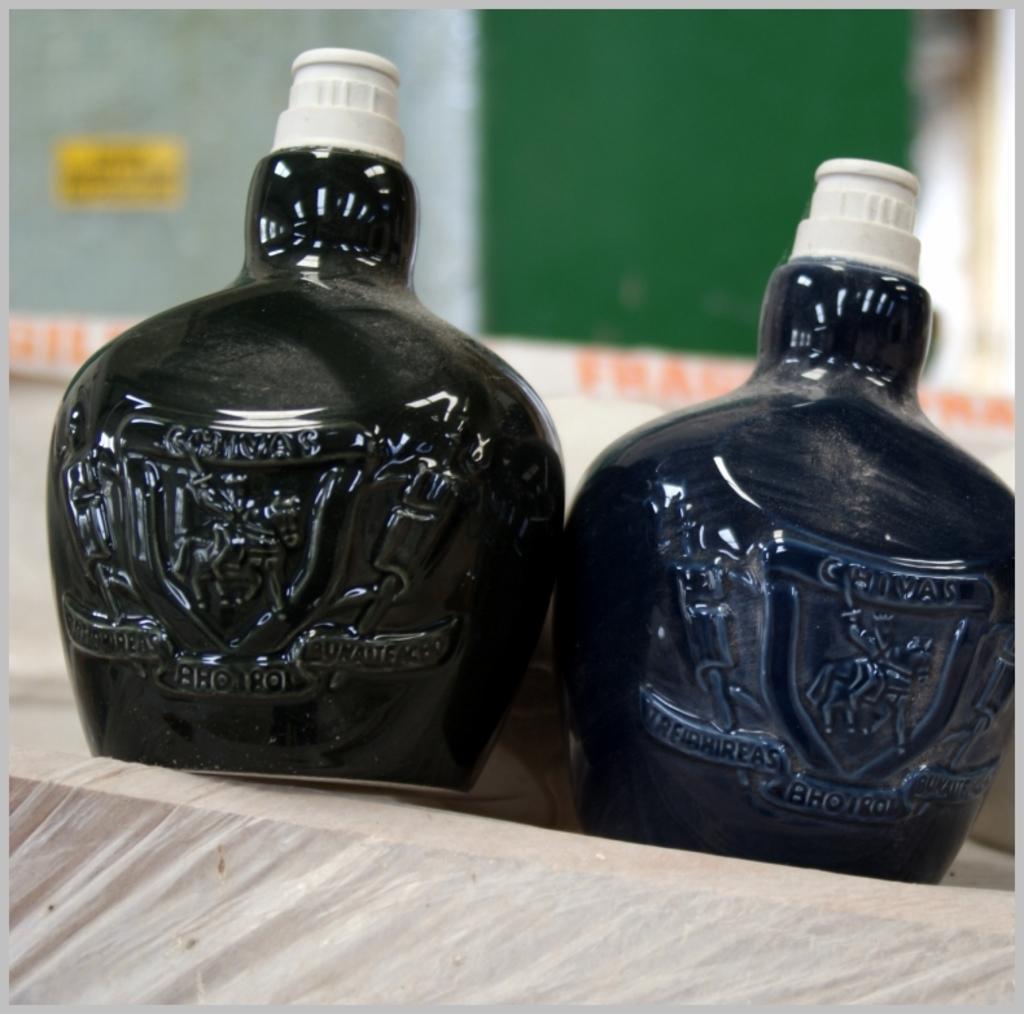Please provide a concise description of this image. In the picture I can see two bottles are kept on the surface. The bottle on the left side is black in color and the bottle on the left side is dark blue in color and the background of the image is blurred. 